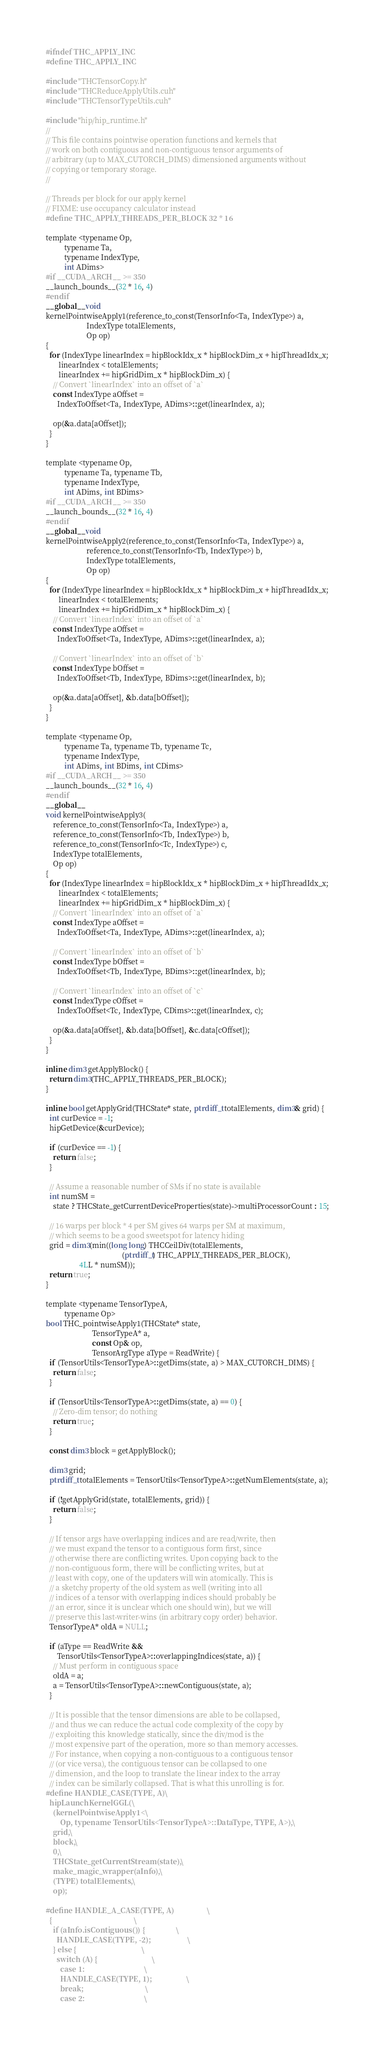<code> <loc_0><loc_0><loc_500><loc_500><_Cuda_>#ifndef THC_APPLY_INC
#define THC_APPLY_INC

#include "THCTensorCopy.h"
#include "THCReduceApplyUtils.cuh"
#include "THCTensorTypeUtils.cuh"

#include "hip/hip_runtime.h"
//
// This file contains pointwise operation functions and kernels that
// work on both contiguous and non-contiguous tensor arguments of
// arbitrary (up to MAX_CUTORCH_DIMS) dimensioned arguments without
// copying or temporary storage.
//

// Threads per block for our apply kernel
// FIXME: use occupancy calculator instead
#define THC_APPLY_THREADS_PER_BLOCK 32 * 16

template <typename Op,
          typename Ta,
          typename IndexType,
          int ADims>
#if __CUDA_ARCH__ >= 350
__launch_bounds__(32 * 16, 4)
#endif
__global__ void
kernelPointwiseApply1(reference_to_const(TensorInfo<Ta, IndexType>) a,
                      IndexType totalElements,
                      Op op)
{
  for (IndexType linearIndex = hipBlockIdx_x * hipBlockDim_x + hipThreadIdx_x;
       linearIndex < totalElements;
       linearIndex += hipGridDim_x * hipBlockDim_x) {
    // Convert `linearIndex` into an offset of `a`
    const IndexType aOffset =
      IndexToOffset<Ta, IndexType, ADims>::get(linearIndex, a);

    op(&a.data[aOffset]);
  }
}

template <typename Op,
          typename Ta, typename Tb,
          typename IndexType,
          int ADims, int BDims>
#if __CUDA_ARCH__ >= 350
__launch_bounds__(32 * 16, 4)
#endif
__global__ void
kernelPointwiseApply2(reference_to_const(TensorInfo<Ta, IndexType>) a,
                      reference_to_const(TensorInfo<Tb, IndexType>) b,
                      IndexType totalElements,
                      Op op)
{
  for (IndexType linearIndex = hipBlockIdx_x * hipBlockDim_x + hipThreadIdx_x;
       linearIndex < totalElements;
       linearIndex += hipGridDim_x * hipBlockDim_x) {
    // Convert `linearIndex` into an offset of `a`
    const IndexType aOffset =
      IndexToOffset<Ta, IndexType, ADims>::get(linearIndex, a);

    // Convert `linearIndex` into an offset of `b`
    const IndexType bOffset =
      IndexToOffset<Tb, IndexType, BDims>::get(linearIndex, b);

    op(&a.data[aOffset], &b.data[bOffset]);
  }
}

template <typename Op,
          typename Ta, typename Tb, typename Tc,
          typename IndexType,
          int ADims, int BDims, int CDims>
#if __CUDA_ARCH__ >= 350
__launch_bounds__(32 * 16, 4)
#endif
__global__
void kernelPointwiseApply3(
    reference_to_const(TensorInfo<Ta, IndexType>) a,
    reference_to_const(TensorInfo<Tb, IndexType>) b,
    reference_to_const(TensorInfo<Tc, IndexType>) c,
    IndexType totalElements,
    Op op)
{
  for (IndexType linearIndex = hipBlockIdx_x * hipBlockDim_x + hipThreadIdx_x;
       linearIndex < totalElements;
       linearIndex += hipGridDim_x * hipBlockDim_x) {
    // Convert `linearIndex` into an offset of `a`
    const IndexType aOffset =
      IndexToOffset<Ta, IndexType, ADims>::get(linearIndex, a);

    // Convert `linearIndex` into an offset of `b`
    const IndexType bOffset =
      IndexToOffset<Tb, IndexType, BDims>::get(linearIndex, b);

    // Convert `linearIndex` into an offset of `c`
    const IndexType cOffset =
      IndexToOffset<Tc, IndexType, CDims>::get(linearIndex, c);

    op(&a.data[aOffset], &b.data[bOffset], &c.data[cOffset]);
  }
}

inline dim3 getApplyBlock() {
  return dim3(THC_APPLY_THREADS_PER_BLOCK);
}

inline bool getApplyGrid(THCState* state, ptrdiff_t totalElements, dim3& grid) {
  int curDevice = -1;
  hipGetDevice(&curDevice);

  if (curDevice == -1) {
    return false;
  }

  // Assume a reasonable number of SMs if no state is available
  int numSM =
    state ? THCState_getCurrentDeviceProperties(state)->multiProcessorCount : 15;

  // 16 warps per block * 4 per SM gives 64 warps per SM at maximum,
  // which seems to be a good sweetspot for latency hiding
  grid = dim3(min((long long) THCCeilDiv(totalElements,
                                         (ptrdiff_t) THC_APPLY_THREADS_PER_BLOCK),
                  4LL * numSM));
  return true;
}

template <typename TensorTypeA,
          typename Op>
bool THC_pointwiseApply1(THCState* state,
                         TensorTypeA* a,
                         const Op& op,
                         TensorArgType aType = ReadWrite) {
  if (TensorUtils<TensorTypeA>::getDims(state, a) > MAX_CUTORCH_DIMS) {
    return false;
  }

  if (TensorUtils<TensorTypeA>::getDims(state, a) == 0) {
    // Zero-dim tensor; do nothing
    return true;
  }

  const dim3 block = getApplyBlock();

  dim3 grid;
  ptrdiff_t totalElements = TensorUtils<TensorTypeA>::getNumElements(state, a);

  if (!getApplyGrid(state, totalElements, grid)) {
    return false;
  }

  // If tensor args have overlapping indices and are read/write, then
  // we must expand the tensor to a contiguous form first, since
  // otherwise there are conflicting writes. Upon copying back to the
  // non-contiguous form, there will be conflicting writes, but at
  // least with copy, one of the updaters will win atomically. This is
  // a sketchy property of the old system as well (writing into all
  // indices of a tensor with overlapping indices should probably be
  // an error, since it is unclear which one should win), but we will
  // preserve this last-writer-wins (in arbitrary copy order) behavior.
  TensorTypeA* oldA = NULL;

  if (aType == ReadWrite &&
      TensorUtils<TensorTypeA>::overlappingIndices(state, a)) {
    // Must perform in contiguous space
    oldA = a;
    a = TensorUtils<TensorTypeA>::newContiguous(state, a);
  }

  // It is possible that the tensor dimensions are able to be collapsed,
  // and thus we can reduce the actual code complexity of the copy by
  // exploiting this knowledge statically, since the div/mod is the
  // most expensive part of the operation, more so than memory accesses.
  // For instance, when copying a non-contiguous to a contiguous tensor
  // (or vice versa), the contiguous tensor can be collapsed to one
  // dimension, and the loop to translate the linear index to the array
  // index can be similarly collapsed. That is what this unrolling is for.
#define HANDLE_CASE(TYPE, A)\
  hipLaunchKernelGGL(\
    (kernelPointwiseApply1<\
        Op, typename TensorUtils<TensorTypeA>::DataType, TYPE, A>),\
    grid,\
    block,\
    0,\
    THCState_getCurrentStream(state),\
    make_magic_wrapper(aInfo),\
    (TYPE) totalElements,\
    op);

#define HANDLE_A_CASE(TYPE, A)                  \
  {                                             \
    if (aInfo.isContiguous()) {                 \
      HANDLE_CASE(TYPE, -2);                    \
    } else {                                    \
      switch (A) {                              \
        case 1:                                 \
        HANDLE_CASE(TYPE, 1);                   \
        break;                                  \
        case 2:                                 \</code> 